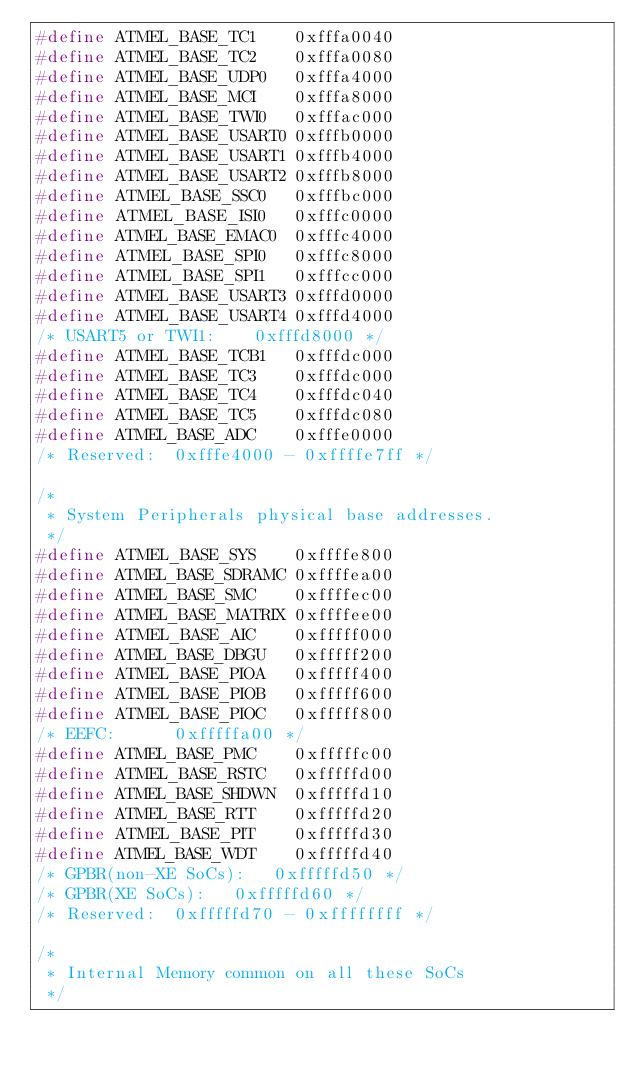<code> <loc_0><loc_0><loc_500><loc_500><_C_>#define ATMEL_BASE_TC1		0xfffa0040
#define ATMEL_BASE_TC2		0xfffa0080
#define ATMEL_BASE_UDP0		0xfffa4000
#define ATMEL_BASE_MCI		0xfffa8000
#define ATMEL_BASE_TWI0		0xfffac000
#define ATMEL_BASE_USART0	0xfffb0000
#define ATMEL_BASE_USART1	0xfffb4000
#define ATMEL_BASE_USART2	0xfffb8000
#define ATMEL_BASE_SSC0		0xfffbc000
#define ATMEL_BASE_ISI0		0xfffc0000
#define ATMEL_BASE_EMAC0	0xfffc4000
#define ATMEL_BASE_SPI0		0xfffc8000
#define ATMEL_BASE_SPI1		0xfffcc000
#define ATMEL_BASE_USART3	0xfffd0000
#define ATMEL_BASE_USART4	0xfffd4000
/* USART5 or TWI1:		0xfffd8000 */
#define ATMEL_BASE_TCB1		0xfffdc000
#define ATMEL_BASE_TC3		0xfffdc000
#define ATMEL_BASE_TC4		0xfffdc040
#define ATMEL_BASE_TC5		0xfffdc080
#define ATMEL_BASE_ADC		0xfffe0000
/* Reserved:	0xfffe4000 - 0xffffe7ff */

/*
 * System Peripherals physical base addresses.
 */
#define ATMEL_BASE_SYS		0xffffe800
#define ATMEL_BASE_SDRAMC	0xffffea00
#define ATMEL_BASE_SMC		0xffffec00
#define ATMEL_BASE_MATRIX	0xffffee00
#define ATMEL_BASE_AIC		0xfffff000
#define ATMEL_BASE_DBGU		0xfffff200
#define ATMEL_BASE_PIOA		0xfffff400
#define ATMEL_BASE_PIOB		0xfffff600
#define ATMEL_BASE_PIOC		0xfffff800
/* EEFC:			0xfffffa00 */
#define ATMEL_BASE_PMC		0xfffffc00
#define ATMEL_BASE_RSTC		0xfffffd00
#define ATMEL_BASE_SHDWN	0xfffffd10
#define ATMEL_BASE_RTT		0xfffffd20
#define ATMEL_BASE_PIT		0xfffffd30
#define ATMEL_BASE_WDT		0xfffffd40
/* GPBR(non-XE SoCs):		0xfffffd50 */
/* GPBR(XE SoCs):		0xfffffd60 */
/* Reserved:	0xfffffd70 - 0xffffffff */

/*
 * Internal Memory common on all these SoCs
 */</code> 